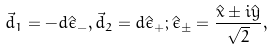Convert formula to latex. <formula><loc_0><loc_0><loc_500><loc_500>\vec { d } _ { 1 } = - d \hat { \epsilon } _ { - } , \vec { d } _ { 2 } = d \hat { \epsilon } _ { + } ; \hat { \epsilon } _ { \pm } = \frac { \hat { x } \pm i \hat { y } } { \sqrt { 2 } } ,</formula> 